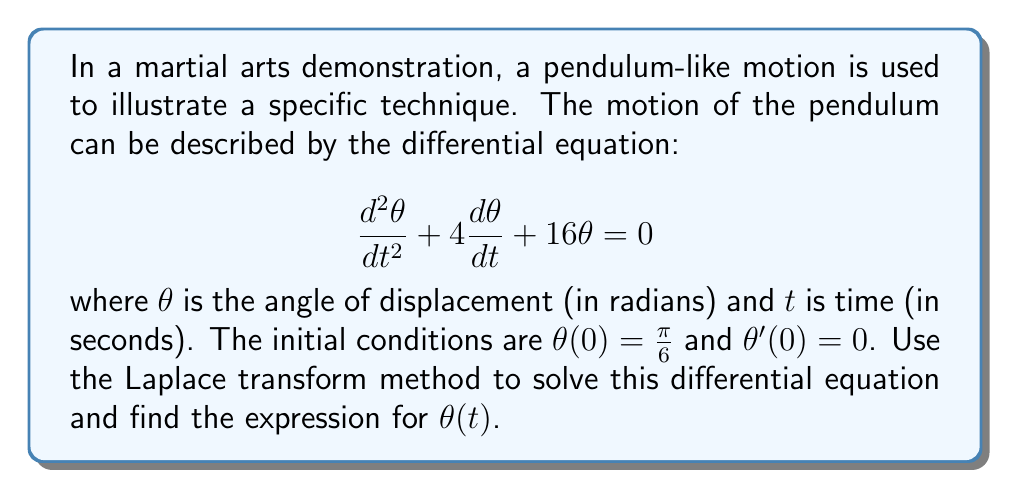Can you solve this math problem? Let's solve this step-by-step using the Laplace transform method:

1) First, let's take the Laplace transform of both sides of the equation. Let $\mathcal{L}\{\theta(t)\} = \Theta(s)$.

   $$\mathcal{L}\{\frac{d^2\theta}{dt^2} + 4\frac{d\theta}{dt} + 16\theta\} = \mathcal{L}\{0\}$$

2) Using Laplace transform properties:

   $$s^2\Theta(s) - s\theta(0) - \theta'(0) + 4[s\Theta(s) - \theta(0)] + 16\Theta(s) = 0$$

3) Substituting the initial conditions $\theta(0) = \frac{\pi}{6}$ and $\theta'(0) = 0$:

   $$s^2\Theta(s) - s\frac{\pi}{6} + 4s\Theta(s) - 4\frac{\pi}{6} + 16\Theta(s) = 0$$

4) Grouping terms with $\Theta(s)$:

   $$(s^2 + 4s + 16)\Theta(s) = s\frac{\pi}{6} + 4\frac{\pi}{6}$$

5) Solving for $\Theta(s)$:

   $$\Theta(s) = \frac{s\frac{\pi}{6} + 4\frac{\pi}{6}}{s^2 + 4s + 16} = \frac{\pi}{6} \cdot \frac{s + 4}{s^2 + 4s + 16}$$

6) The denominator can be factored as $(s + 2)^2 + 12$. We can use partial fraction decomposition:

   $$\Theta(s) = \frac{\pi}{6} \cdot \frac{A(s+2) + B}{(s+2)^2 + 12}$$

   where $A$ and $B$ are constants to be determined.

7) Solving for $A$ and $B$, we get $A = \frac{1}{3}$ and $B = \frac{2}{3}$.

8) Now we can write:

   $$\Theta(s) = \frac{\pi}{18} \cdot \frac{s+2}{(s+2)^2 + 12} + \frac{\pi}{9} \cdot \frac{1}{(s+2)^2 + 12}$$

9) Using inverse Laplace transform:

   $$\theta(t) = \frac{\pi}{18}e^{-2t}\cos(\sqrt{12}t) + \frac{\pi}{9\sqrt{12}}e^{-2t}\sin(\sqrt{12}t)$$

10) Simplifying:

    $$\theta(t) = \frac{\pi}{18}e^{-2t}(\cos(2\sqrt{3}t) + \frac{1}{\sqrt{3}}\sin(2\sqrt{3}t))$$

This is the final expression for $\theta(t)$.
Answer: $$\theta(t) = \frac{\pi}{18}e^{-2t}(\cos(2\sqrt{3}t) + \frac{1}{\sqrt{3}}\sin(2\sqrt{3}t))$$ 